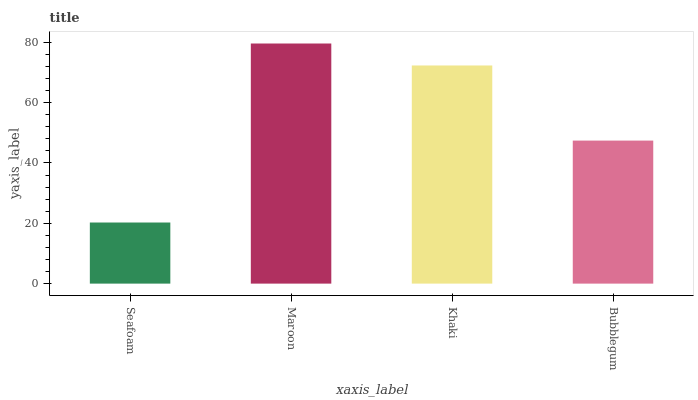Is Seafoam the minimum?
Answer yes or no. Yes. Is Maroon the maximum?
Answer yes or no. Yes. Is Khaki the minimum?
Answer yes or no. No. Is Khaki the maximum?
Answer yes or no. No. Is Maroon greater than Khaki?
Answer yes or no. Yes. Is Khaki less than Maroon?
Answer yes or no. Yes. Is Khaki greater than Maroon?
Answer yes or no. No. Is Maroon less than Khaki?
Answer yes or no. No. Is Khaki the high median?
Answer yes or no. Yes. Is Bubblegum the low median?
Answer yes or no. Yes. Is Maroon the high median?
Answer yes or no. No. Is Maroon the low median?
Answer yes or no. No. 